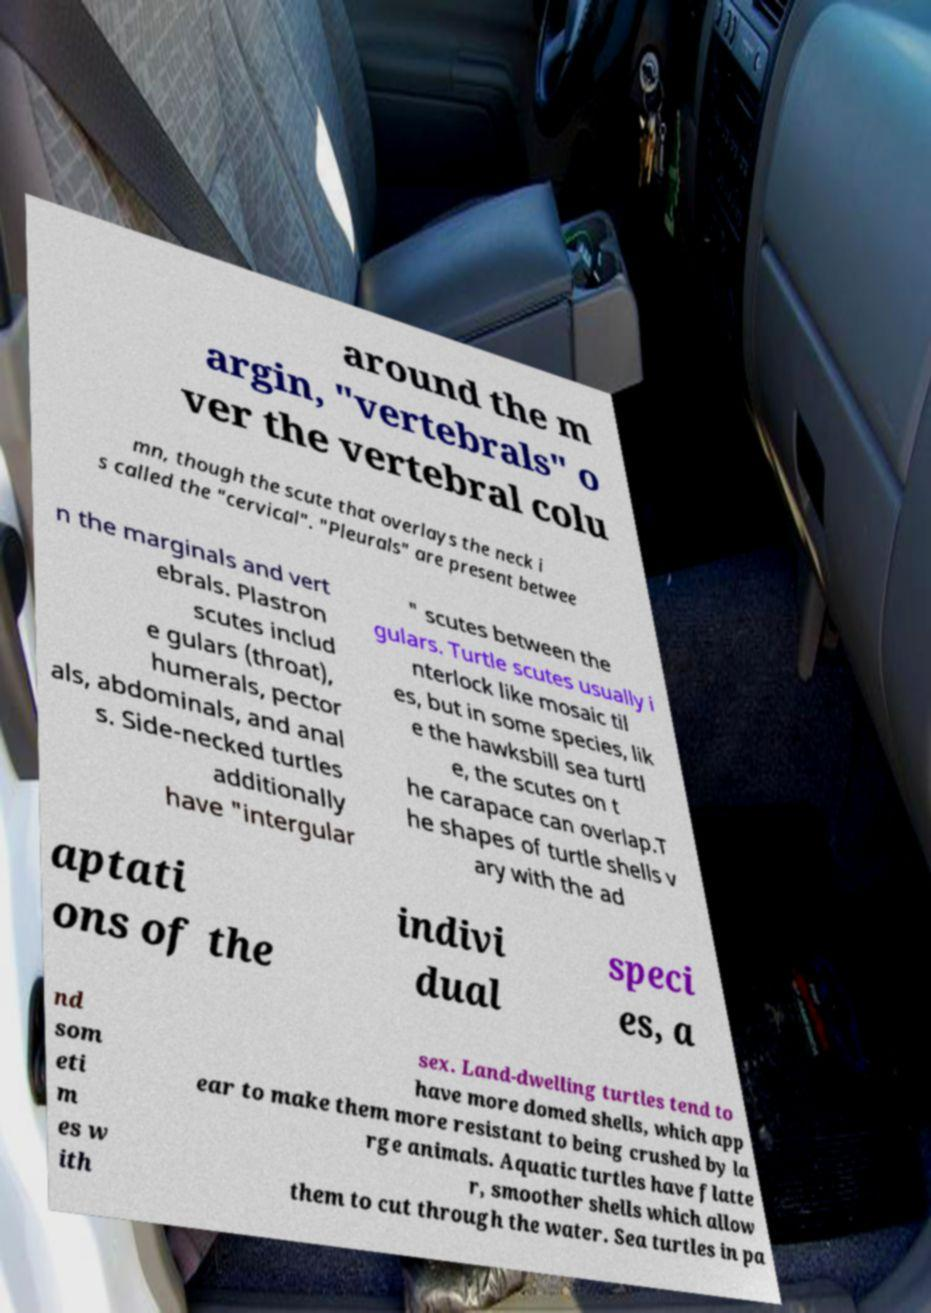There's text embedded in this image that I need extracted. Can you transcribe it verbatim? around the m argin, "vertebrals" o ver the vertebral colu mn, though the scute that overlays the neck i s called the "cervical". "Pleurals" are present betwee n the marginals and vert ebrals. Plastron scutes includ e gulars (throat), humerals, pector als, abdominals, and anal s. Side-necked turtles additionally have "intergular " scutes between the gulars. Turtle scutes usually i nterlock like mosaic til es, but in some species, lik e the hawksbill sea turtl e, the scutes on t he carapace can overlap.T he shapes of turtle shells v ary with the ad aptati ons of the indivi dual speci es, a nd som eti m es w ith sex. Land-dwelling turtles tend to have more domed shells, which app ear to make them more resistant to being crushed by la rge animals. Aquatic turtles have flatte r, smoother shells which allow them to cut through the water. Sea turtles in pa 